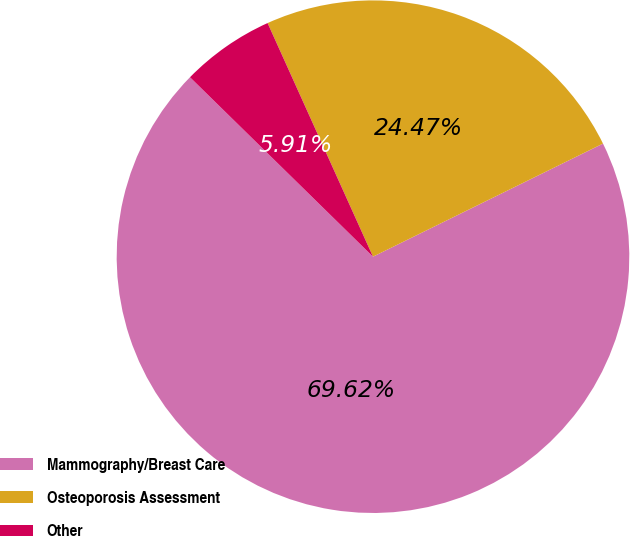<chart> <loc_0><loc_0><loc_500><loc_500><pie_chart><fcel>Mammography/Breast Care<fcel>Osteoporosis Assessment<fcel>Other<nl><fcel>69.61%<fcel>24.47%<fcel>5.91%<nl></chart> 